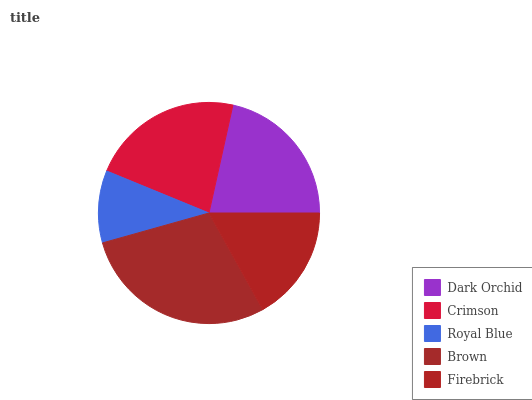Is Royal Blue the minimum?
Answer yes or no. Yes. Is Brown the maximum?
Answer yes or no. Yes. Is Crimson the minimum?
Answer yes or no. No. Is Crimson the maximum?
Answer yes or no. No. Is Crimson greater than Dark Orchid?
Answer yes or no. Yes. Is Dark Orchid less than Crimson?
Answer yes or no. Yes. Is Dark Orchid greater than Crimson?
Answer yes or no. No. Is Crimson less than Dark Orchid?
Answer yes or no. No. Is Dark Orchid the high median?
Answer yes or no. Yes. Is Dark Orchid the low median?
Answer yes or no. Yes. Is Brown the high median?
Answer yes or no. No. Is Royal Blue the low median?
Answer yes or no. No. 